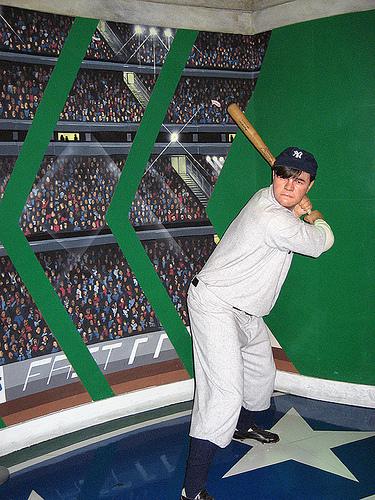Are the people in the background real?
Quick response, please. No. Is this player going to hit the ball?
Answer briefly. Yes. What sport is this?
Concise answer only. Baseball. 